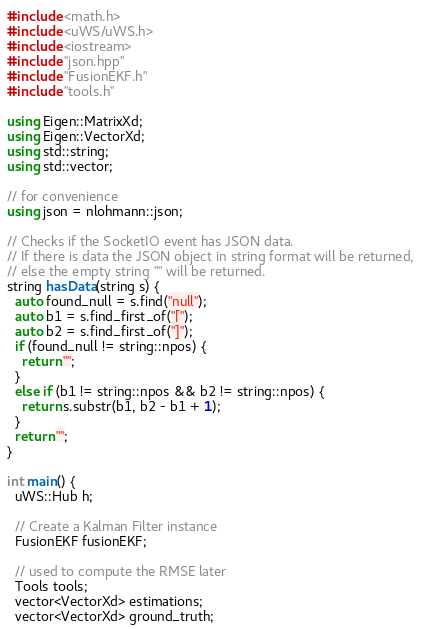<code> <loc_0><loc_0><loc_500><loc_500><_C++_>#include <math.h>
#include <uWS/uWS.h>
#include <iostream>
#include "json.hpp"
#include "FusionEKF.h"
#include "tools.h"

using Eigen::MatrixXd;
using Eigen::VectorXd;
using std::string;
using std::vector;

// for convenience
using json = nlohmann::json;

// Checks if the SocketIO event has JSON data.
// If there is data the JSON object in string format will be returned,
// else the empty string "" will be returned.
string hasData(string s) {
  auto found_null = s.find("null");
  auto b1 = s.find_first_of("[");
  auto b2 = s.find_first_of("]");
  if (found_null != string::npos) {
    return "";
  }
  else if (b1 != string::npos && b2 != string::npos) {
    return s.substr(b1, b2 - b1 + 1);
  }
  return "";
}

int main() {
  uWS::Hub h;

  // Create a Kalman Filter instance
  FusionEKF fusionEKF;

  // used to compute the RMSE later
  Tools tools;
  vector<VectorXd> estimations;
  vector<VectorXd> ground_truth;
</code> 